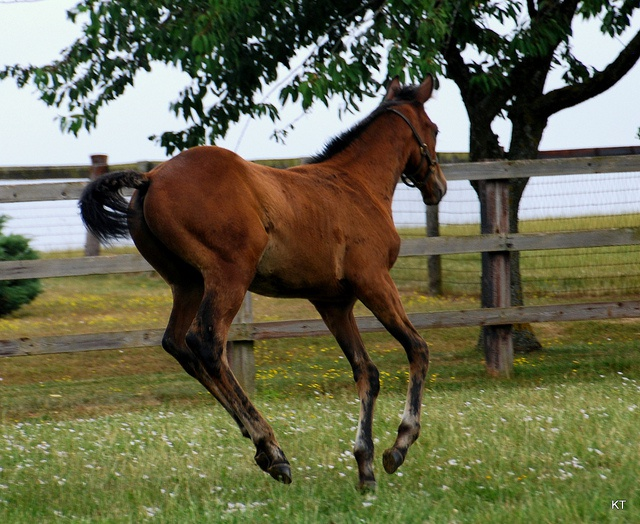Describe the objects in this image and their specific colors. I can see a horse in white, black, maroon, and brown tones in this image. 